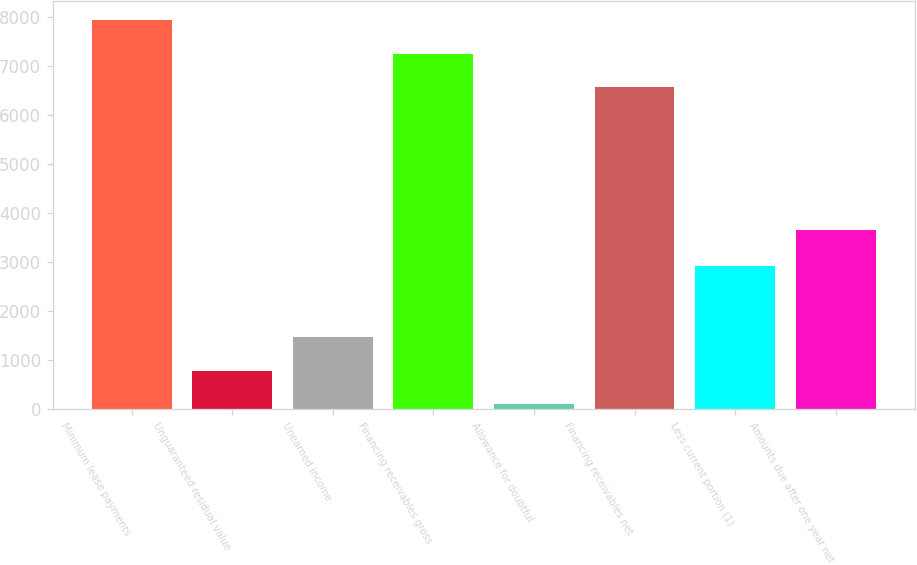Convert chart. <chart><loc_0><loc_0><loc_500><loc_500><bar_chart><fcel>Minimum lease payments<fcel>Unguaranteed residual value<fcel>Unearned income<fcel>Financing receivables gross<fcel>Allowance for doubtful<fcel>Financing receivables net<fcel>Less current portion (1)<fcel>Amounts due after one year net<nl><fcel>7929.2<fcel>779.6<fcel>1464.2<fcel>7244.6<fcel>95<fcel>6560<fcel>2918<fcel>3642<nl></chart> 